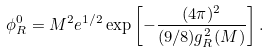<formula> <loc_0><loc_0><loc_500><loc_500>\phi _ { R } ^ { 0 } = M ^ { 2 } e ^ { 1 / 2 } \exp \left [ - \frac { ( 4 \pi ) ^ { 2 } } { ( 9 / 8 ) g _ { R } ^ { 2 } ( M ) } \right ] .</formula> 